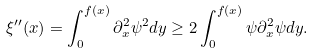<formula> <loc_0><loc_0><loc_500><loc_500>\xi ^ { \prime \prime } ( x ) = \int _ { 0 } ^ { f ( x ) } \partial _ { x } ^ { 2 } \psi ^ { 2 } d y \geq 2 \int _ { 0 } ^ { f ( x ) } \psi \partial _ { x } ^ { 2 } \psi d y .</formula> 